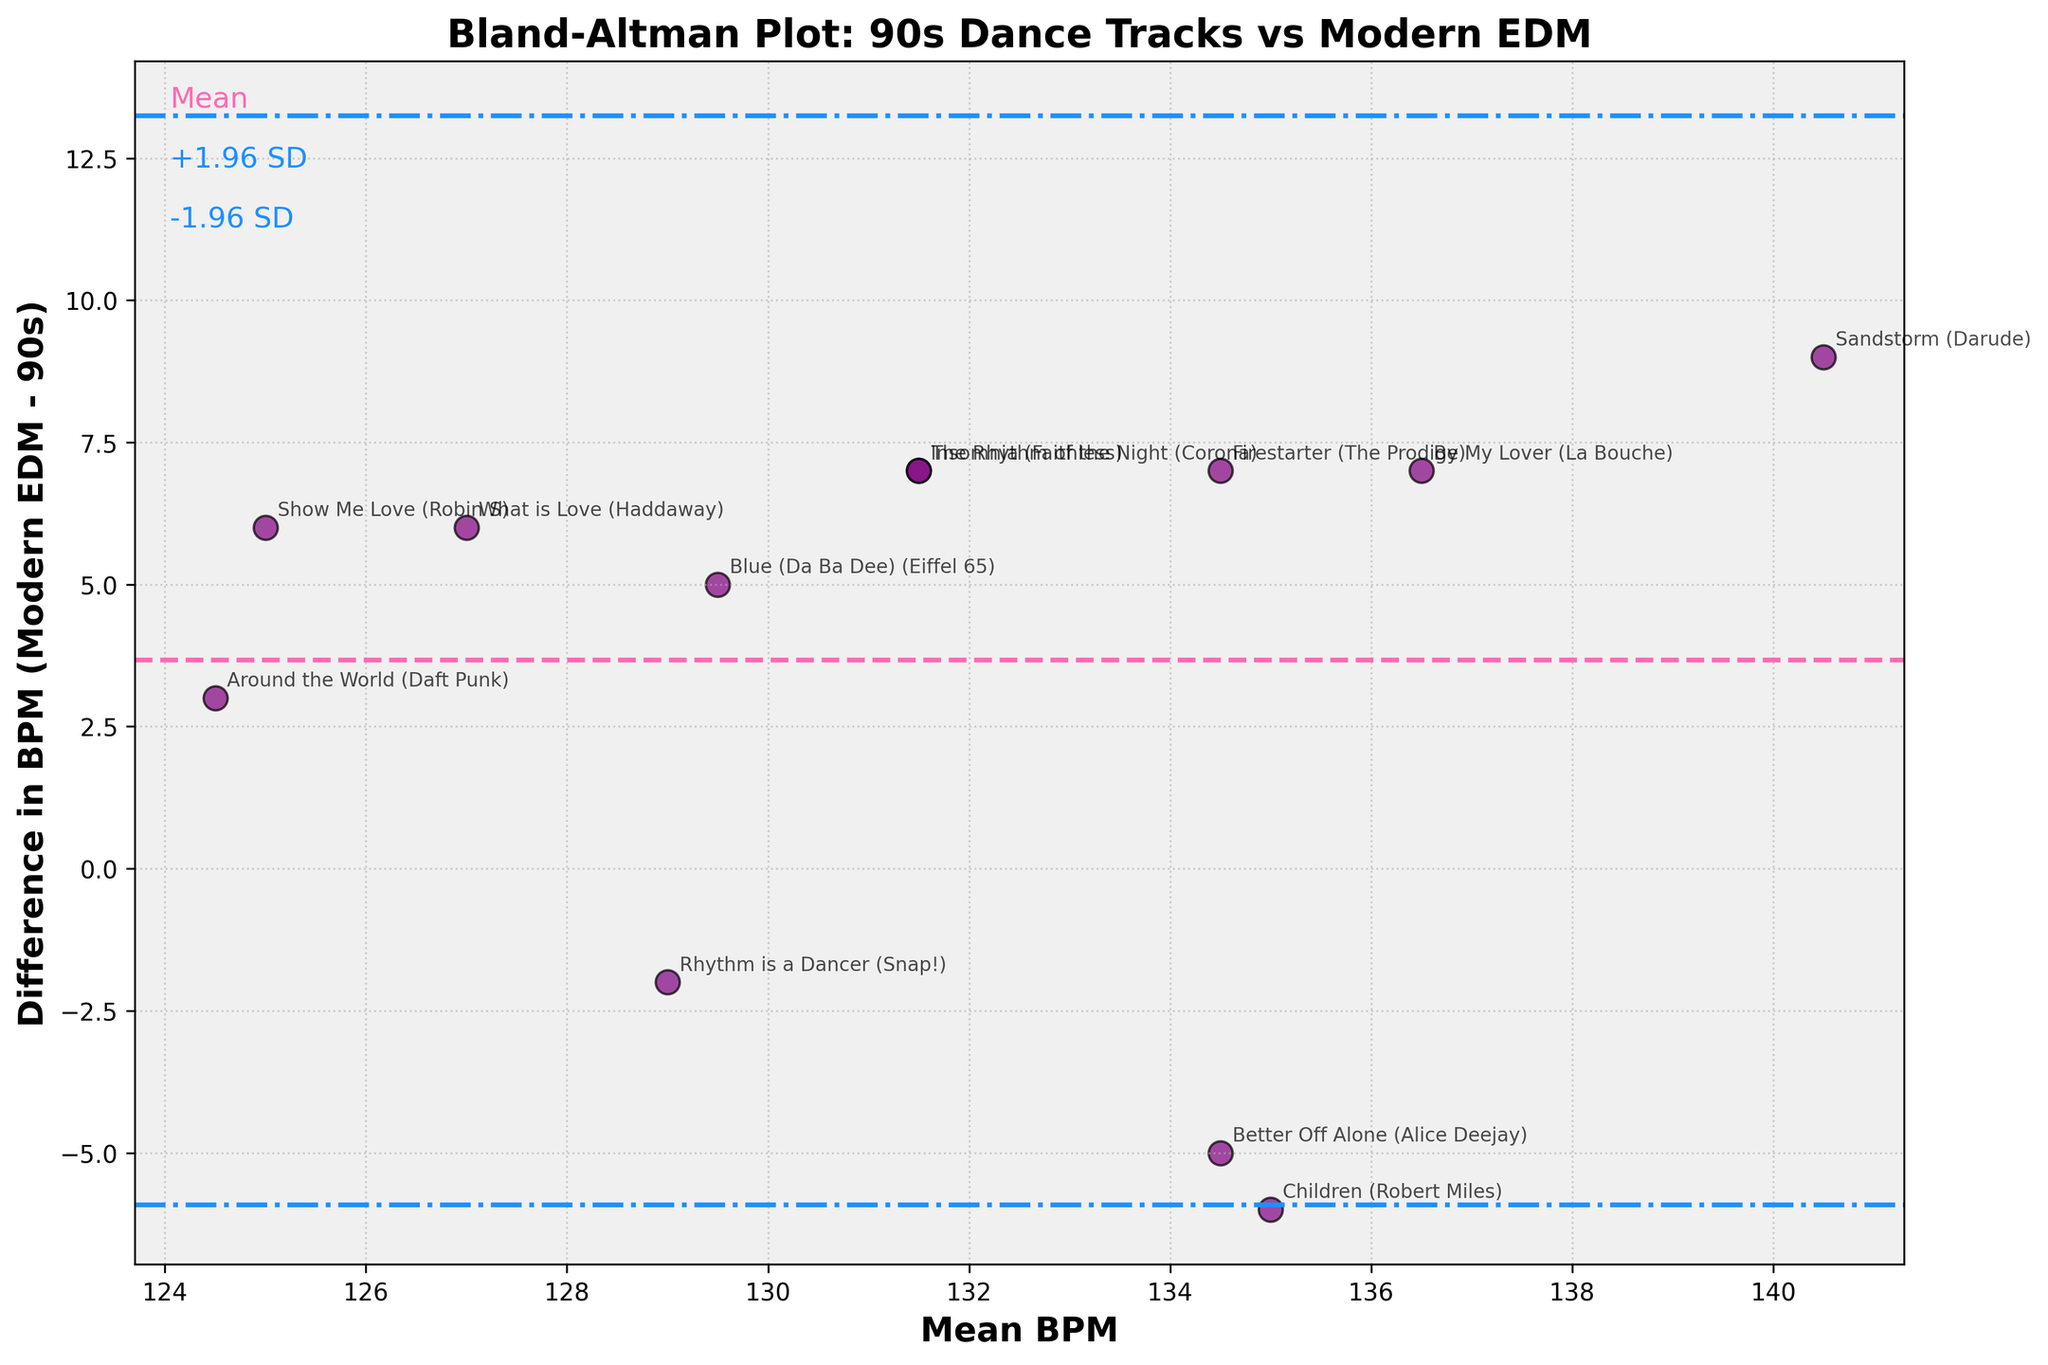What is the title of the Bland-Altman plot? The title of the plot is visible at the top of the figure. It summarizes the overall comparison being made in the plot.
Answer: Bland-Altman Plot: 90s Dance Tracks vs Modern EDM How many tracks are compared in the plot? Each point on the Bland-Altman plot represents one track, so you can count all the data points to get the total number of tracks.
Answer: 12 What does the y-axis represent? The label on the y-axis provides an explanation of what is being measured. It represents the difference in BPM between modern EDM tracks and 90s dance tracks.
Answer: Difference in BPM (Modern EDM - 90s) What is the mean difference in BPM between 90s dance tracks and modern EDM? This is indicated by the value at the horizontal dashed line, which is typically annotated as "Mean".
Answer: ~4.25 BPM What are the upper and lower limits of agreement in the plot? These limits are shown as dashed-dotted lines and are generally displayed as ±1.96 standard deviations from the mean difference line.
Answer: ~14.28 BPM and ~ -5.77 BPM Which track has the largest positive difference in BPM between modern EDM and 90s dance tracks? The data point farthest upward from the mean line on the plot corresponds to the track with the largest positive BPM difference.
Answer: "Sandstorm" (Darude) Which track has the greatest mean BPM value according to the plot? The highest mean BPM value can be found by identifying the rightmost data point on the x-axis.
Answer: "Children" (Robert Miles) Are there any tracks where the modern EDM BPM is lower than the 90s BPM? Look for points below the mean difference line; these indicate where modern EDM BPM is less than the 90s BPM for those specific tracks.
Answer: No Which track shows the smallest BPM difference and what is its value? The smallest BPM difference is found by locating the data point closest to the mean difference line horizontally, and checking the corresponding y-value.
Answer: "Rhythm is a Dancer" (Snap!), -2 BPM 